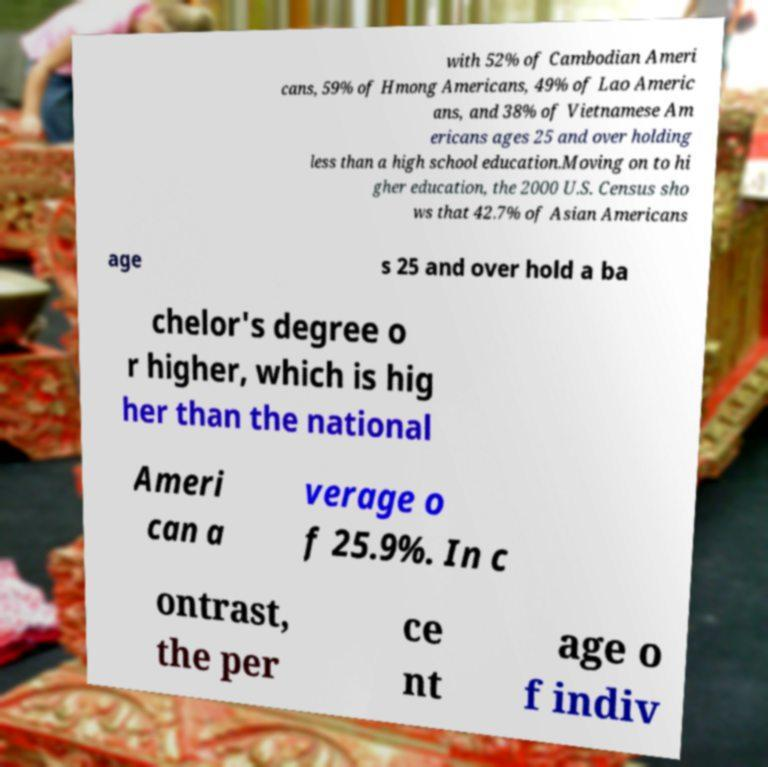There's text embedded in this image that I need extracted. Can you transcribe it verbatim? with 52% of Cambodian Ameri cans, 59% of Hmong Americans, 49% of Lao Americ ans, and 38% of Vietnamese Am ericans ages 25 and over holding less than a high school education.Moving on to hi gher education, the 2000 U.S. Census sho ws that 42.7% of Asian Americans age s 25 and over hold a ba chelor's degree o r higher, which is hig her than the national Ameri can a verage o f 25.9%. In c ontrast, the per ce nt age o f indiv 